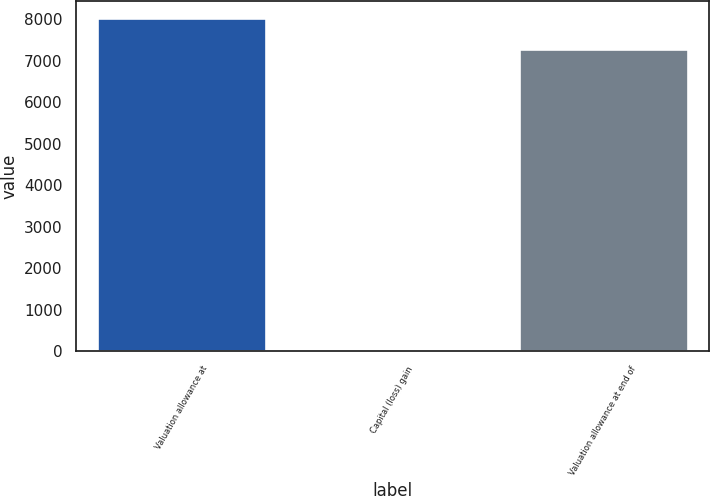<chart> <loc_0><loc_0><loc_500><loc_500><bar_chart><fcel>Valuation allowance at<fcel>Capital (loss) gain<fcel>Valuation allowance at end of<nl><fcel>8030.5<fcel>63<fcel>7294<nl></chart> 